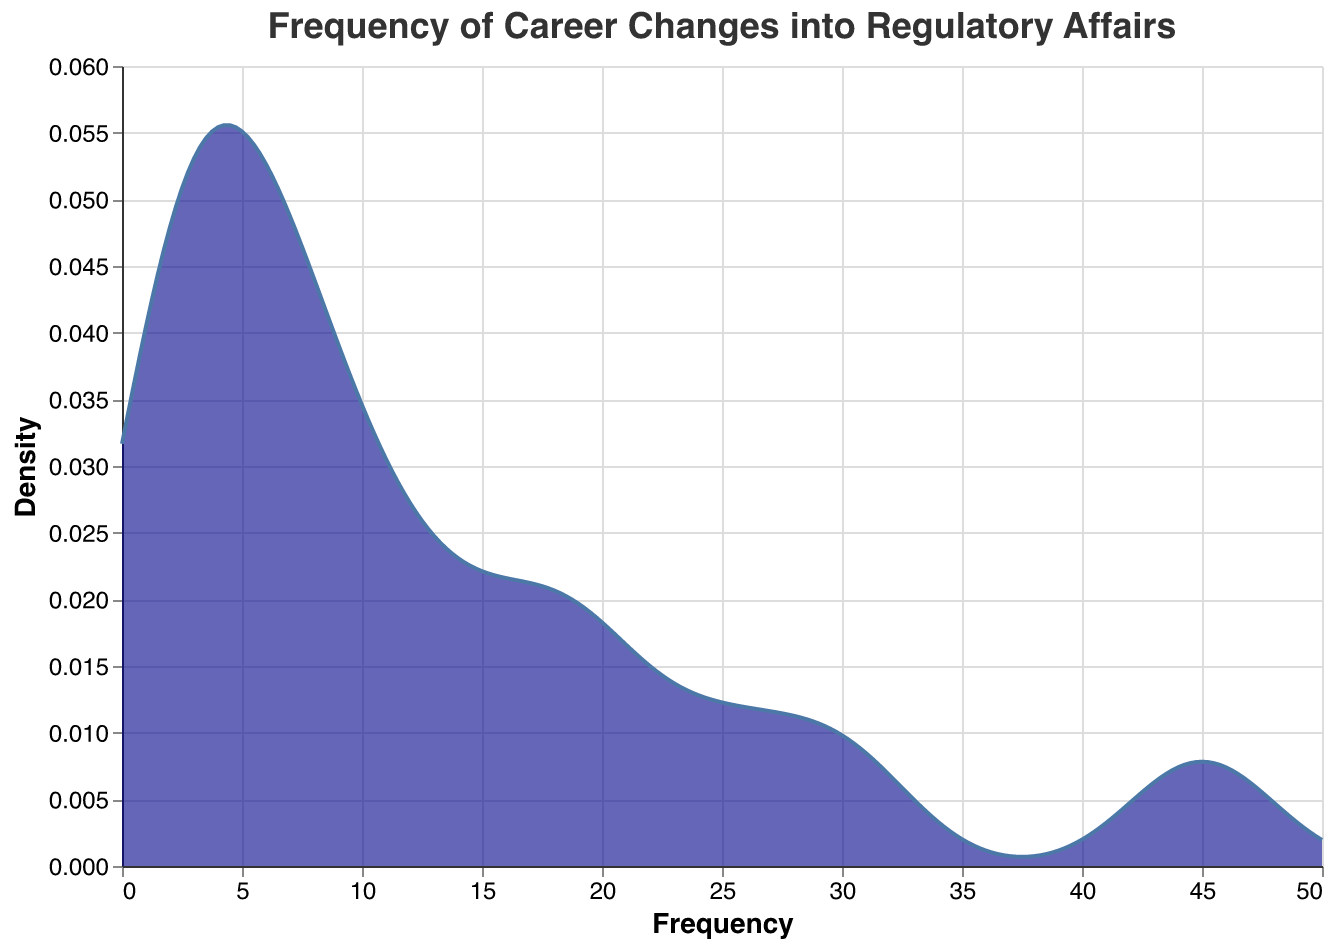What is the title of the plot? The title of the plot appears at the top and represents the main focus of the visual. In this case, it reads "Frequency of Career Changes into Regulatory Affairs".
Answer: Frequency of Career Changes into Regulatory Affairs What axis represents frequency in this plot? The "x" axis is labeled as "Frequency" which indicates that it represents the frequency of career changes into regulatory affairs from various prior professions.
Answer: x-axis How many different professions are shown in the data? From the data values provided, there are 17 different professions listed that have seen career changes into regulatory affairs.
Answer: 17 Which profession appears to have the highest density of people transitioning into regulatory affairs? By looking at the density curve, the peak density indicates the profession with the highest number of transitions, which corresponds to being a Research Scientist.
Answer: Research Scientist What is the approximate frequency where the highest density occurs? The peak of the density plot occurs around a frequency value of 45. This suggests that the highest density of career changes comes from professions with frequencies around this value.
Answer: 45 How does the density of career changes from Pharmacists compare to Clinical Trial Managers? From the density plot, the value around 30 (for Pharmacists) and around 25 (for Clinical Trial Managers) would have associated density values. We can visually compare these densities on the plot, and it appears that the density around 30 is slightly higher than around 25.
Answer: Density around 30 is slightly higher than around 25 What is the density of career changes from professions with a frequency less than 10? The density curve covers various frequencies; for frequencies below 10, the density curve will show lower values compared to higher frequency careers. Visually, it is evident that the density is much lower for professions with frequencies less than 10.
Answer: Lower density for frequency < 10 Can you identify multiple professions with similar frequencies based on the density plot? From the density plot, there are peaks and troughs that indicate frequencies of transitions. Professions like Legal Advisor and Production Technician might share similar densities since their frequencies (both 2) are very similar.
Answer: Legal Advisor and Production Technician Which profession has the least number of career changes into regulatory affairs? Viewing the data list shows that Finance Analyst has the lowest frequency with only 1 career change into regulatory affairs.
Answer: Finance Analyst How many professions have a frequency of career changes into regulatory affairs between 10 and 20? The densities along the curve between the frequencies of 10 and 20 will help us count. From the list, these professions are Regulatory Compliance Officer, Healthcare Consultant, Pharmaceutical Sales Representative, Nurse, Pharmacovigilance Specialist, and Quality Assurance Specialist, totaling six professions.
Answer: 6 